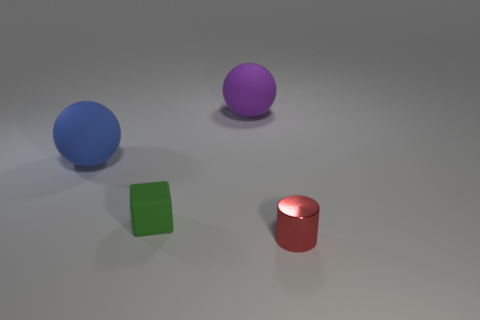Do the small thing behind the shiny thing and the purple thing have the same material?
Offer a very short reply. Yes. Are there more tiny green cubes that are to the left of the small red metallic thing than big blue objects that are in front of the blue rubber sphere?
Ensure brevity in your answer.  Yes. What number of objects are large objects on the right side of the green cube or large rubber balls?
Ensure brevity in your answer.  2. There is a small green thing that is made of the same material as the large blue sphere; what is its shape?
Provide a short and direct response. Cube. Is there any other thing that is the same shape as the small green rubber object?
Give a very brief answer. No. What is the color of the object that is both in front of the big blue thing and left of the small red metal cylinder?
Your answer should be compact. Green. What number of cylinders are large green matte objects or big purple objects?
Keep it short and to the point. 0. How many purple balls are the same size as the matte cube?
Your answer should be compact. 0. There is a tiny object that is right of the tiny matte cube; how many large purple things are to the right of it?
Make the answer very short. 0. What size is the thing that is both to the right of the small matte object and to the left of the cylinder?
Your response must be concise. Large. 